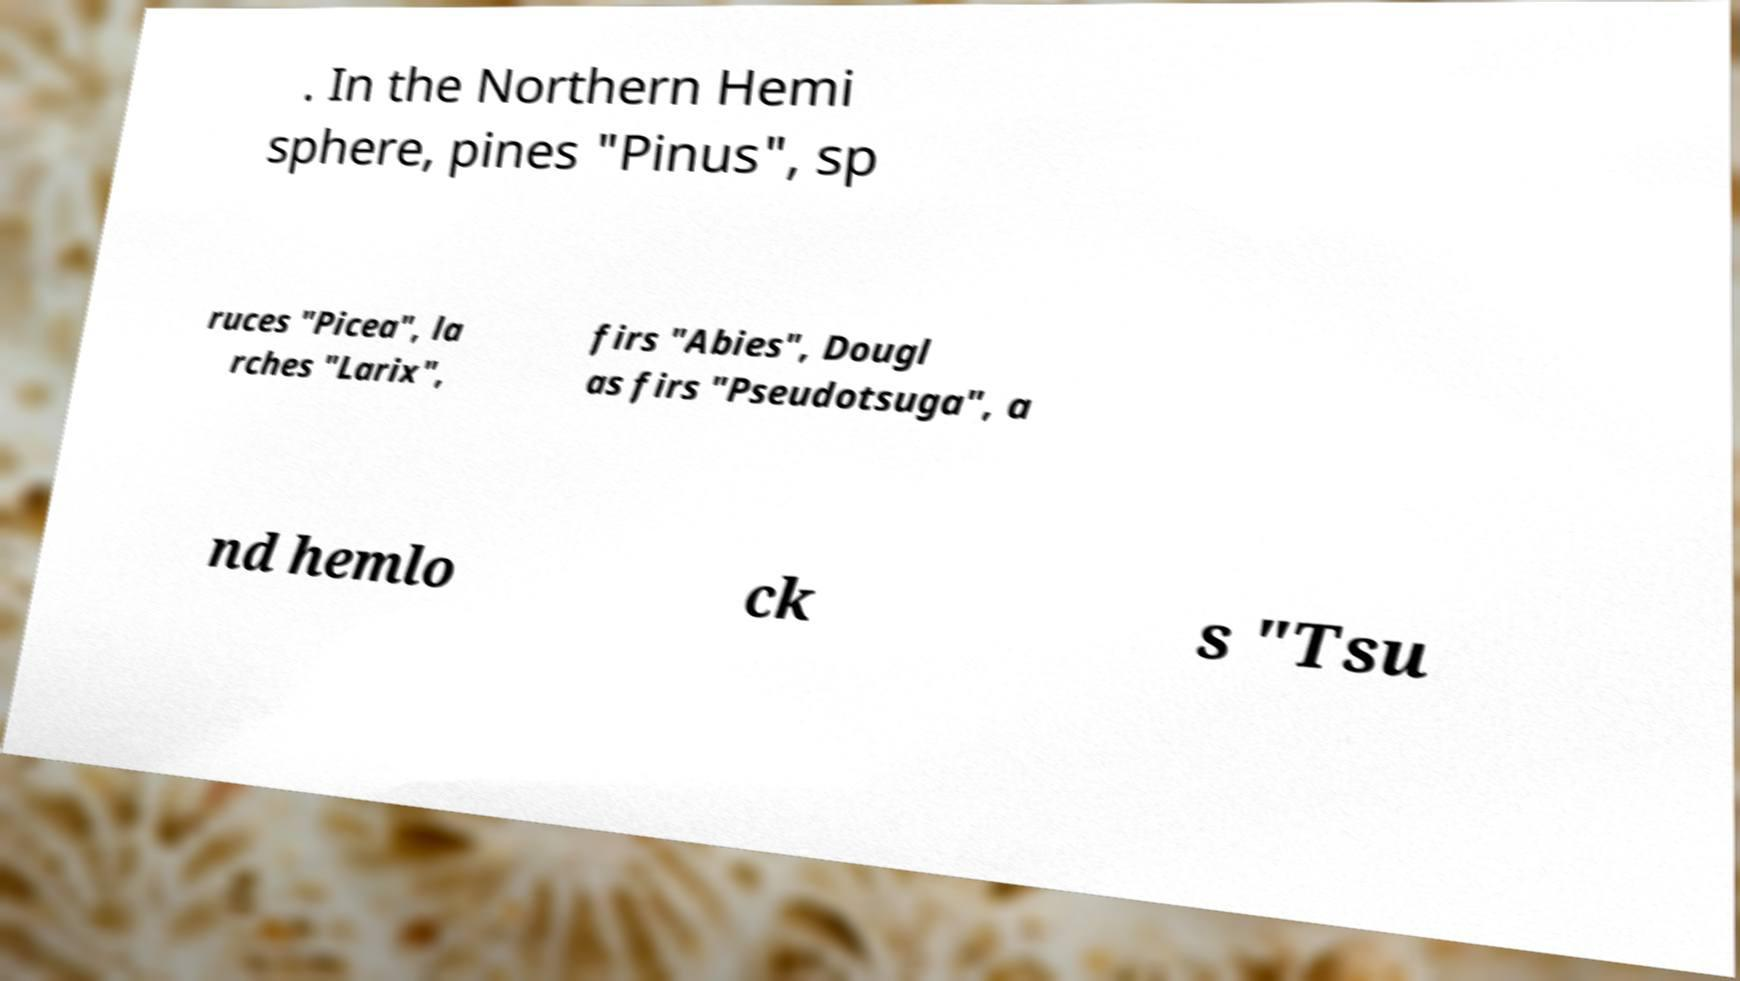Could you assist in decoding the text presented in this image and type it out clearly? . In the Northern Hemi sphere, pines "Pinus", sp ruces "Picea", la rches "Larix", firs "Abies", Dougl as firs "Pseudotsuga", a nd hemlo ck s "Tsu 